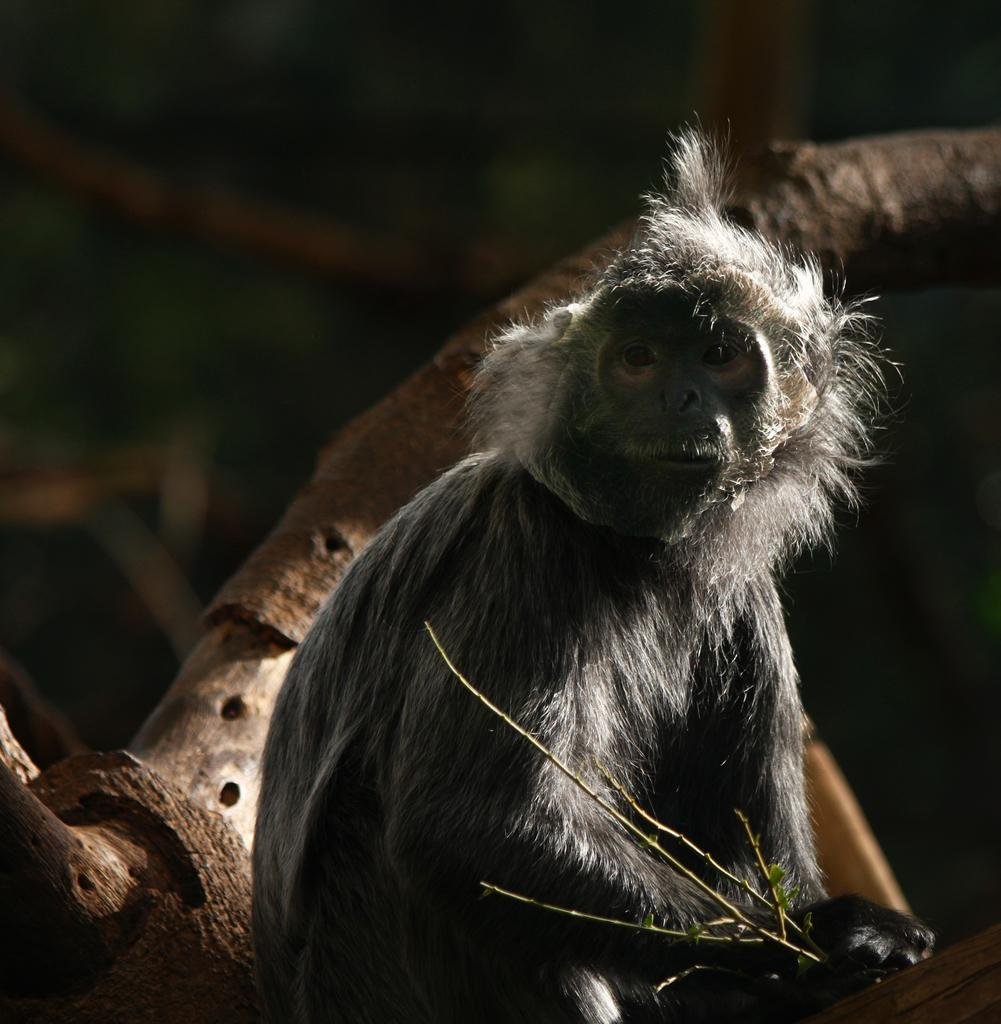What is the main subject in the foreground of the image? There is a monkey in the foreground of the image. What can be seen in the background of the image? There are wooden sticks and some objects in the background of the image. What type of grain can be seen growing in the image? There is no grain visible in the image; it features a monkey in the foreground and wooden sticks and objects in the background. What sense is the monkey using to interact with the wooden sticks in the image? The image does not provide information about the monkey's senses or its interaction with the wooden sticks. 